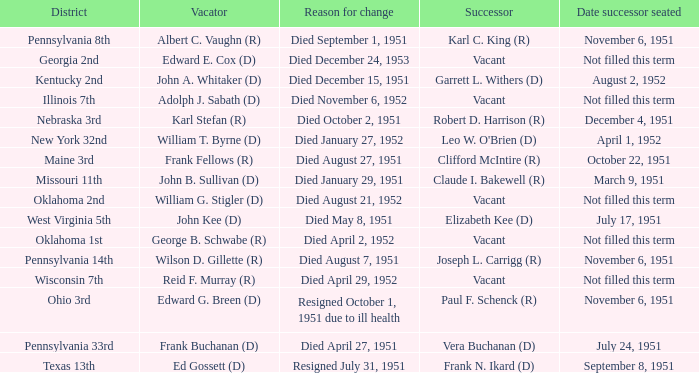How many vacators were in the Pennsylvania 33rd district? 1.0. 